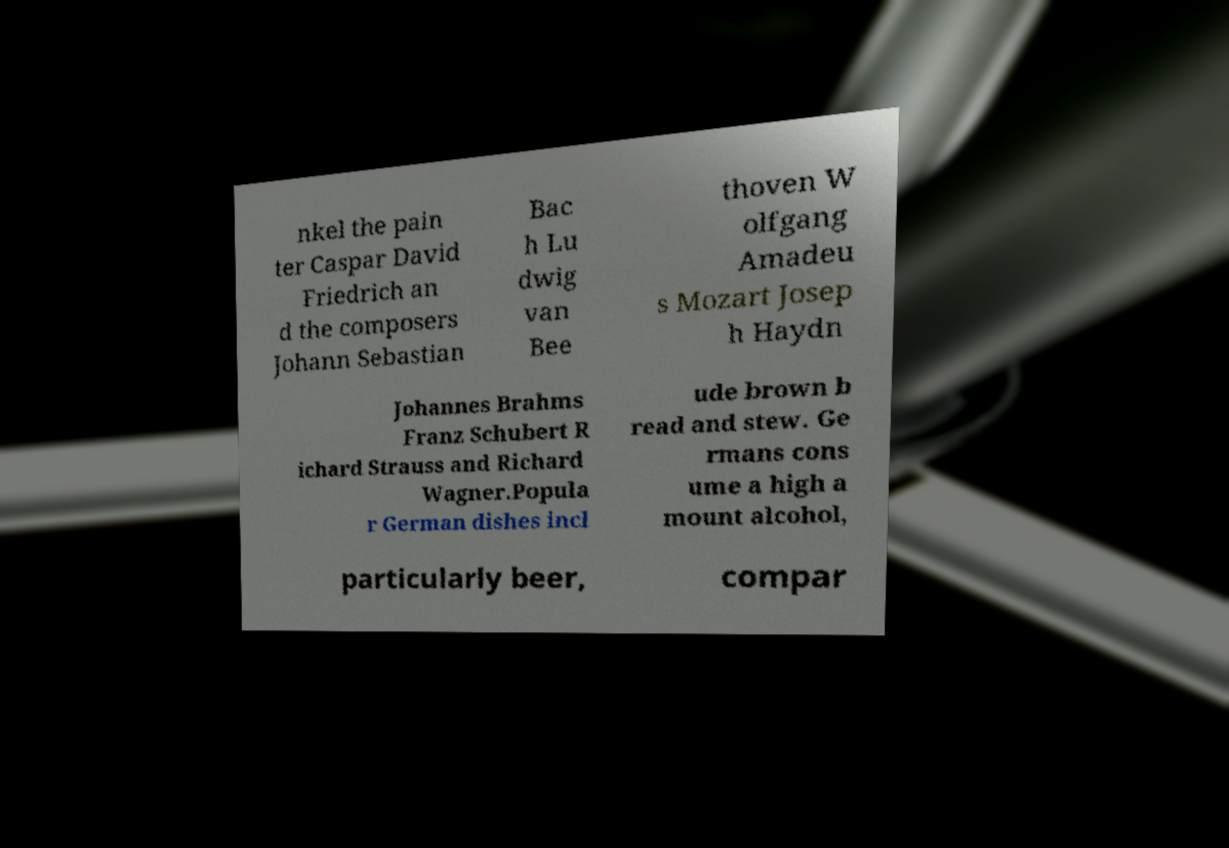Can you read and provide the text displayed in the image?This photo seems to have some interesting text. Can you extract and type it out for me? nkel the pain ter Caspar David Friedrich an d the composers Johann Sebastian Bac h Lu dwig van Bee thoven W olfgang Amadeu s Mozart Josep h Haydn Johannes Brahms Franz Schubert R ichard Strauss and Richard Wagner.Popula r German dishes incl ude brown b read and stew. Ge rmans cons ume a high a mount alcohol, particularly beer, compar 